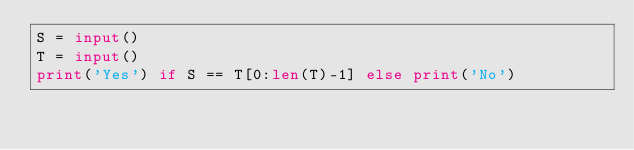<code> <loc_0><loc_0><loc_500><loc_500><_Python_>S = input()
T = input()
print('Yes') if S == T[0:len(T)-1] else print('No')</code> 